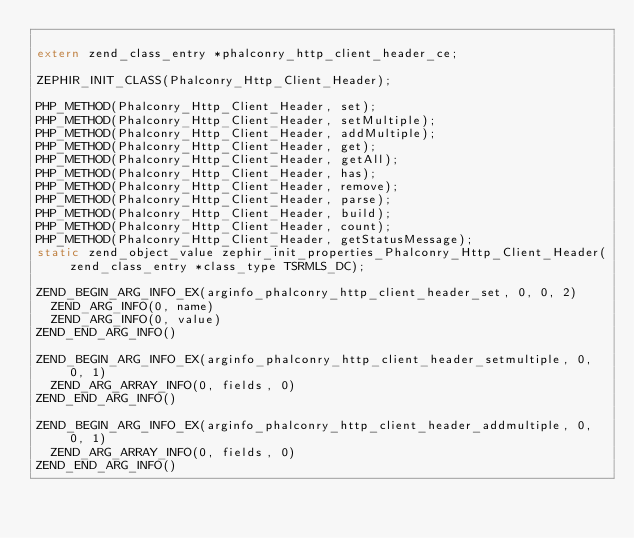Convert code to text. <code><loc_0><loc_0><loc_500><loc_500><_C_>
extern zend_class_entry *phalconry_http_client_header_ce;

ZEPHIR_INIT_CLASS(Phalconry_Http_Client_Header);

PHP_METHOD(Phalconry_Http_Client_Header, set);
PHP_METHOD(Phalconry_Http_Client_Header, setMultiple);
PHP_METHOD(Phalconry_Http_Client_Header, addMultiple);
PHP_METHOD(Phalconry_Http_Client_Header, get);
PHP_METHOD(Phalconry_Http_Client_Header, getAll);
PHP_METHOD(Phalconry_Http_Client_Header, has);
PHP_METHOD(Phalconry_Http_Client_Header, remove);
PHP_METHOD(Phalconry_Http_Client_Header, parse);
PHP_METHOD(Phalconry_Http_Client_Header, build);
PHP_METHOD(Phalconry_Http_Client_Header, count);
PHP_METHOD(Phalconry_Http_Client_Header, getStatusMessage);
static zend_object_value zephir_init_properties_Phalconry_Http_Client_Header(zend_class_entry *class_type TSRMLS_DC);

ZEND_BEGIN_ARG_INFO_EX(arginfo_phalconry_http_client_header_set, 0, 0, 2)
	ZEND_ARG_INFO(0, name)
	ZEND_ARG_INFO(0, value)
ZEND_END_ARG_INFO()

ZEND_BEGIN_ARG_INFO_EX(arginfo_phalconry_http_client_header_setmultiple, 0, 0, 1)
	ZEND_ARG_ARRAY_INFO(0, fields, 0)
ZEND_END_ARG_INFO()

ZEND_BEGIN_ARG_INFO_EX(arginfo_phalconry_http_client_header_addmultiple, 0, 0, 1)
	ZEND_ARG_ARRAY_INFO(0, fields, 0)
ZEND_END_ARG_INFO()
</code> 